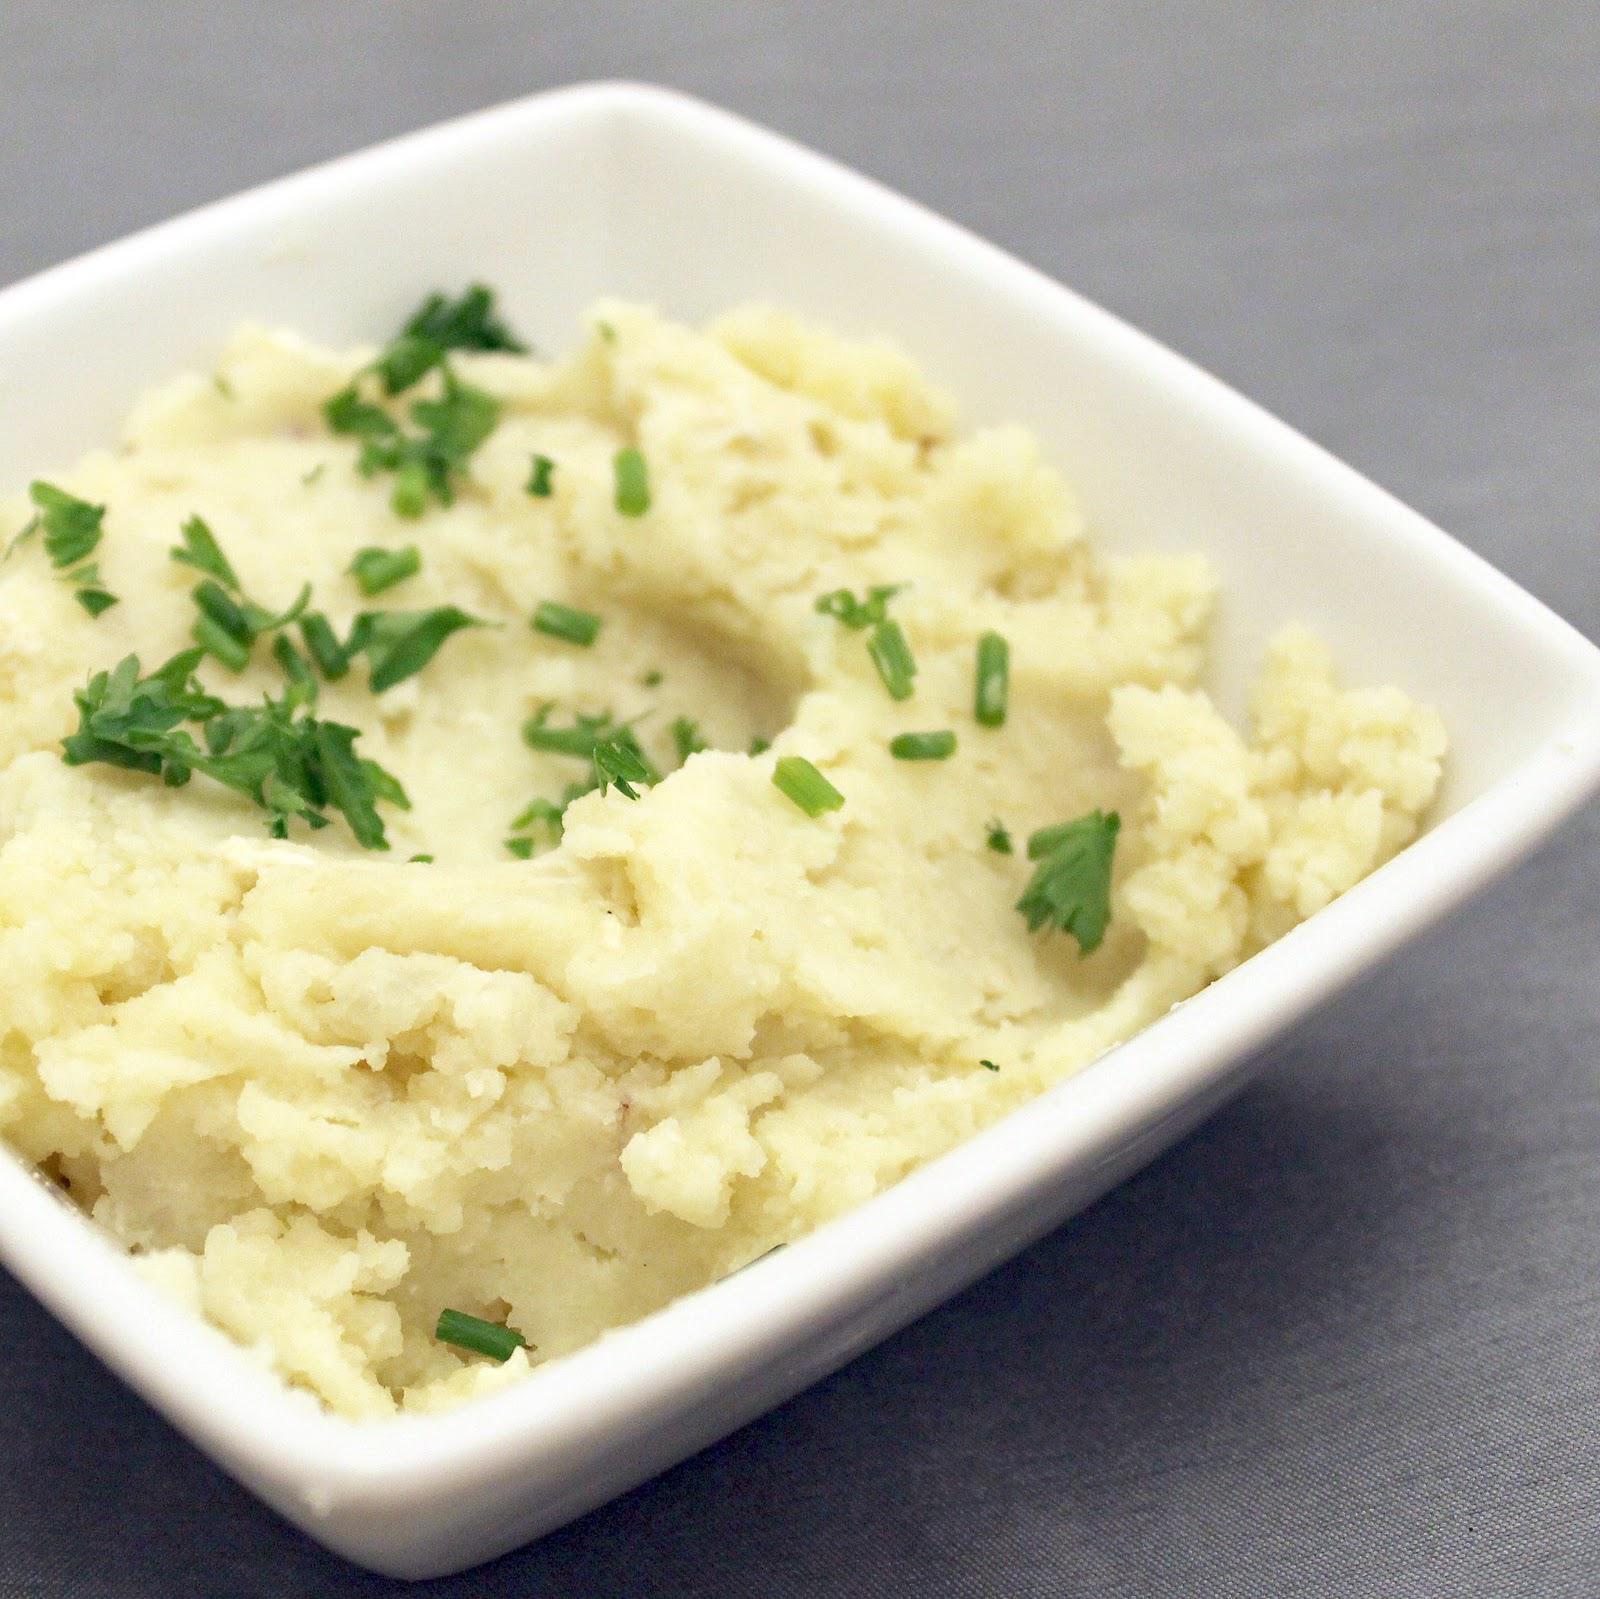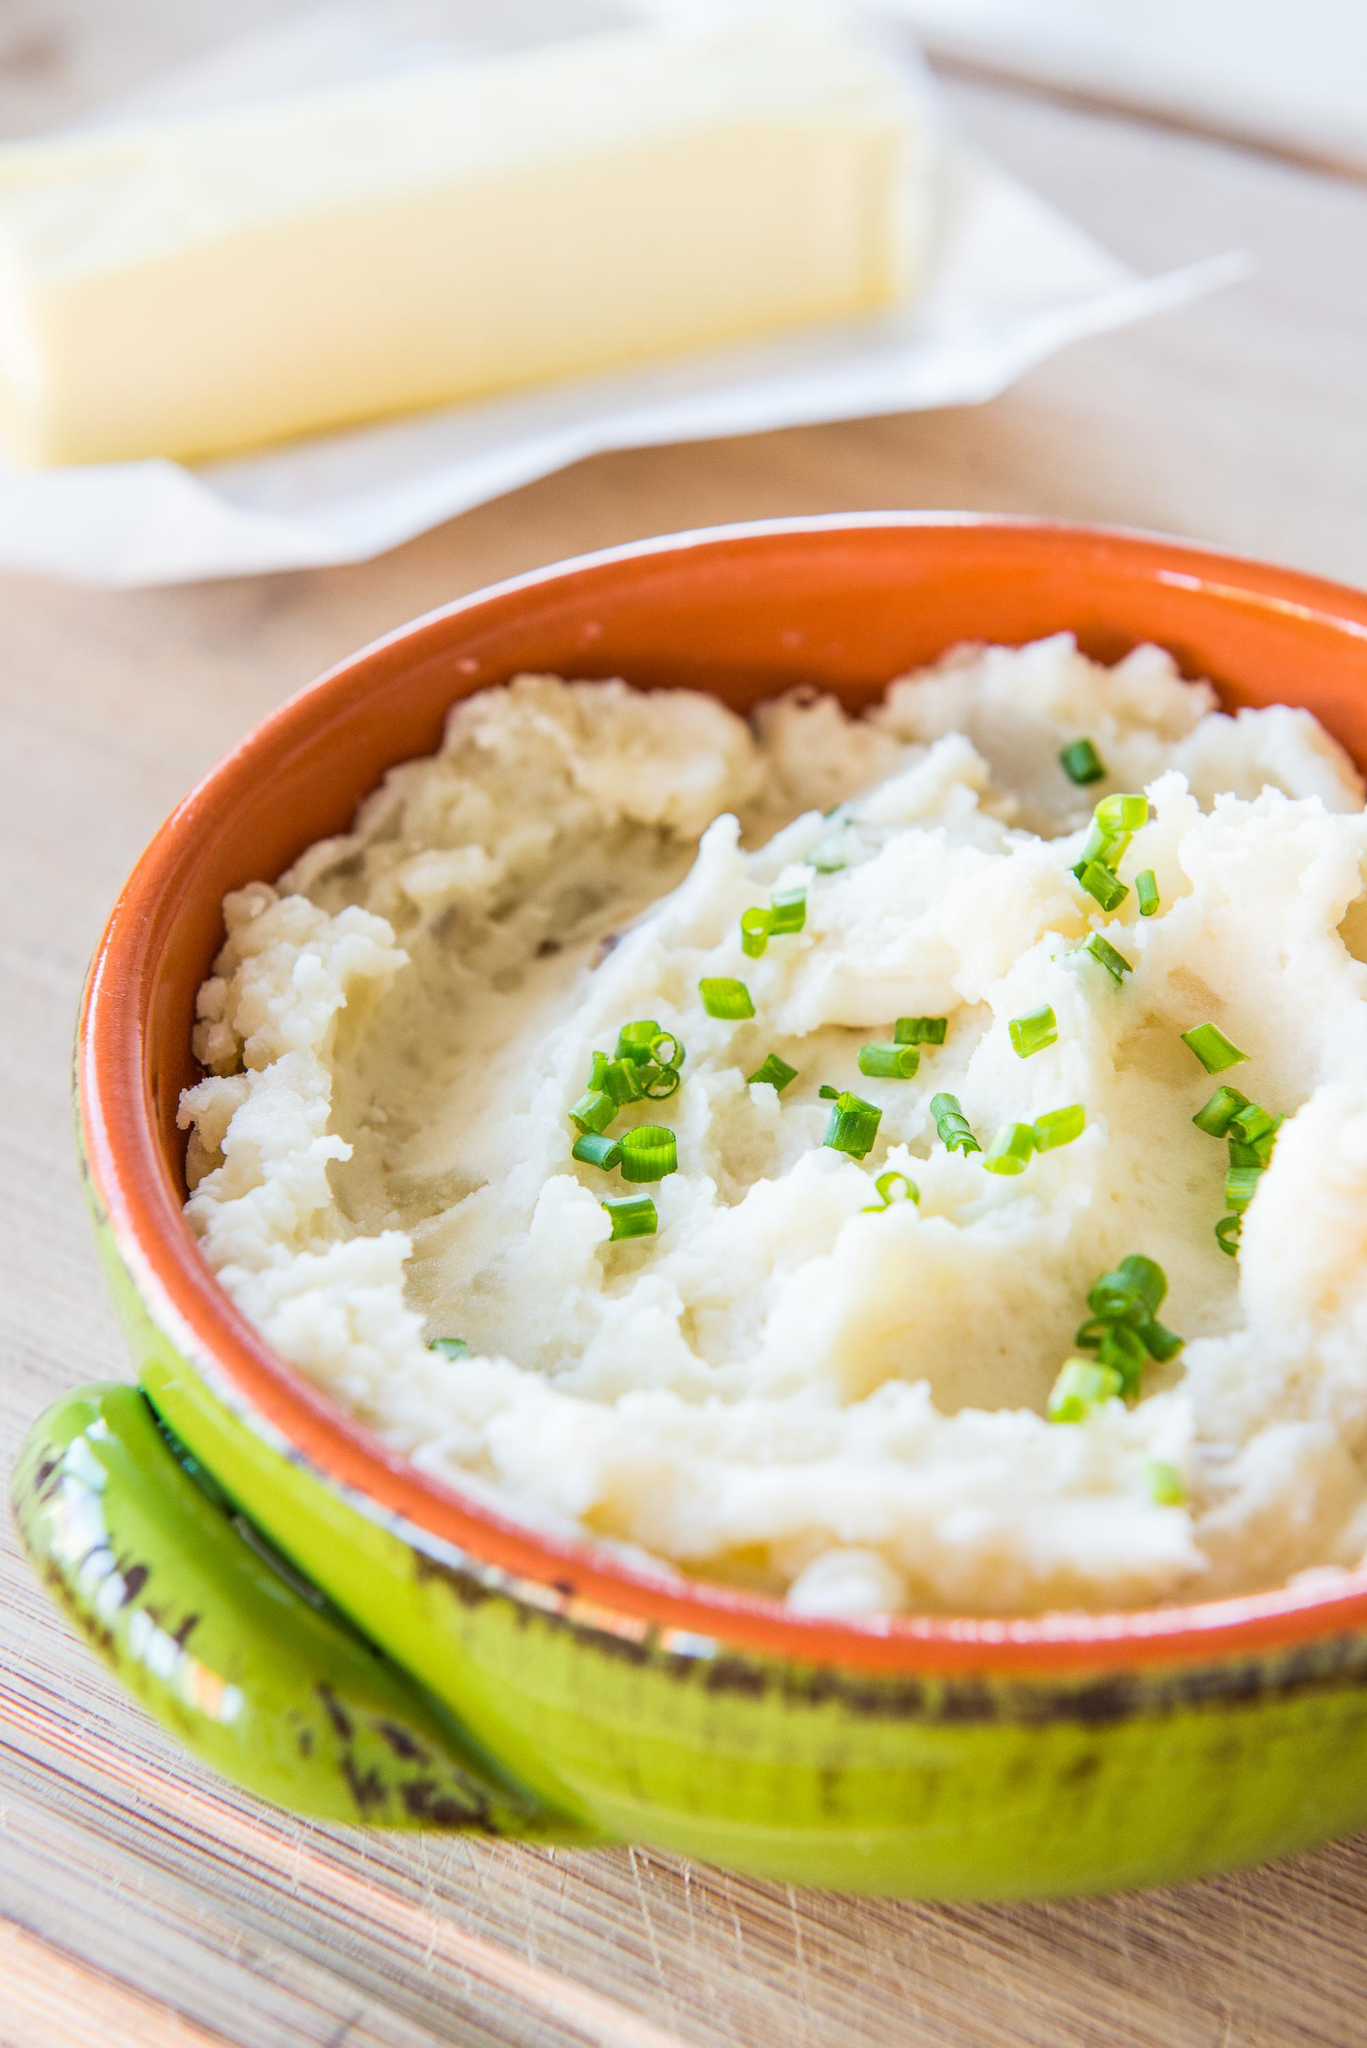The first image is the image on the left, the second image is the image on the right. Examine the images to the left and right. Is the description "A silver spoon is set near the dish on the right." accurate? Answer yes or no. No. The first image is the image on the left, the second image is the image on the right. For the images displayed, is the sentence "The left image shows a white bowl of food with a utensil handle sticking out, and the right image includes a spoon that is not sticking out of the food." factually correct? Answer yes or no. No. 